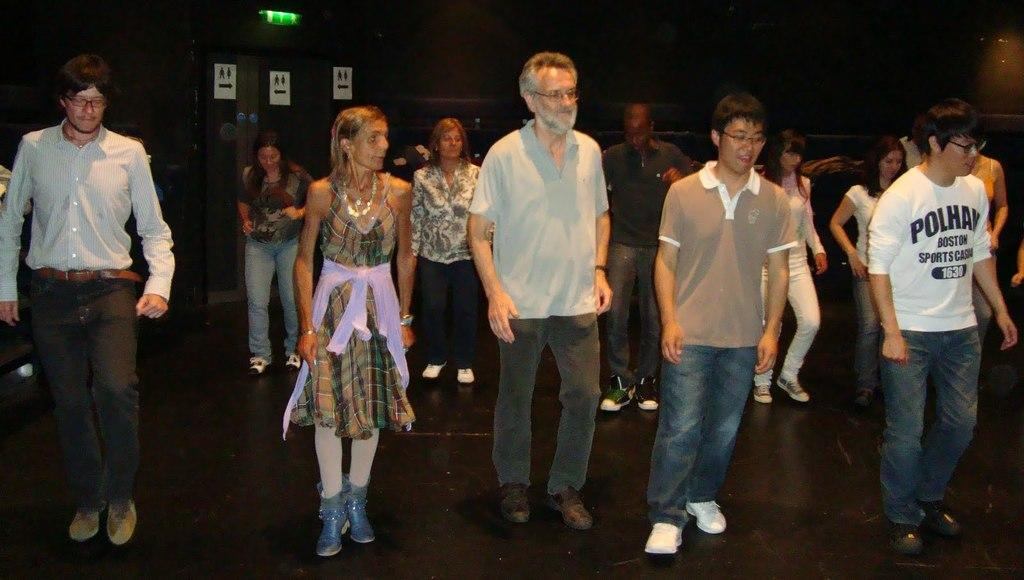What are the people in the image doing? The people in the image are on the floor. What can be seen in the background of the image? The background of the image is dark, and there are boards visible. What type of pear is being used as a heart-shaped decoration in the image? There is no pear or heart-shaped decoration present in the image. 